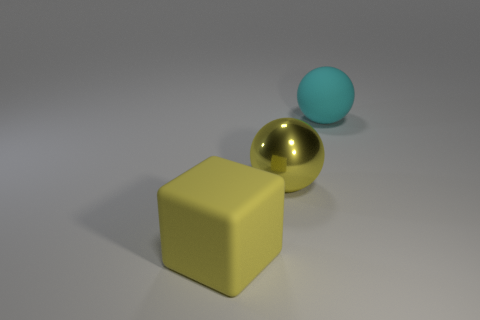Subtract 1 spheres. How many spheres are left? 1 Subtract all blue spheres. How many brown blocks are left? 0 Add 2 large cyan rubber cylinders. How many objects exist? 5 Subtract all yellow balls. How many balls are left? 1 Subtract 1 yellow spheres. How many objects are left? 2 Subtract all spheres. How many objects are left? 1 Subtract all brown balls. Subtract all yellow cylinders. How many balls are left? 2 Subtract all metal spheres. Subtract all large yellow shiny balls. How many objects are left? 1 Add 3 large balls. How many large balls are left? 5 Add 3 large cyan shiny cylinders. How many large cyan shiny cylinders exist? 3 